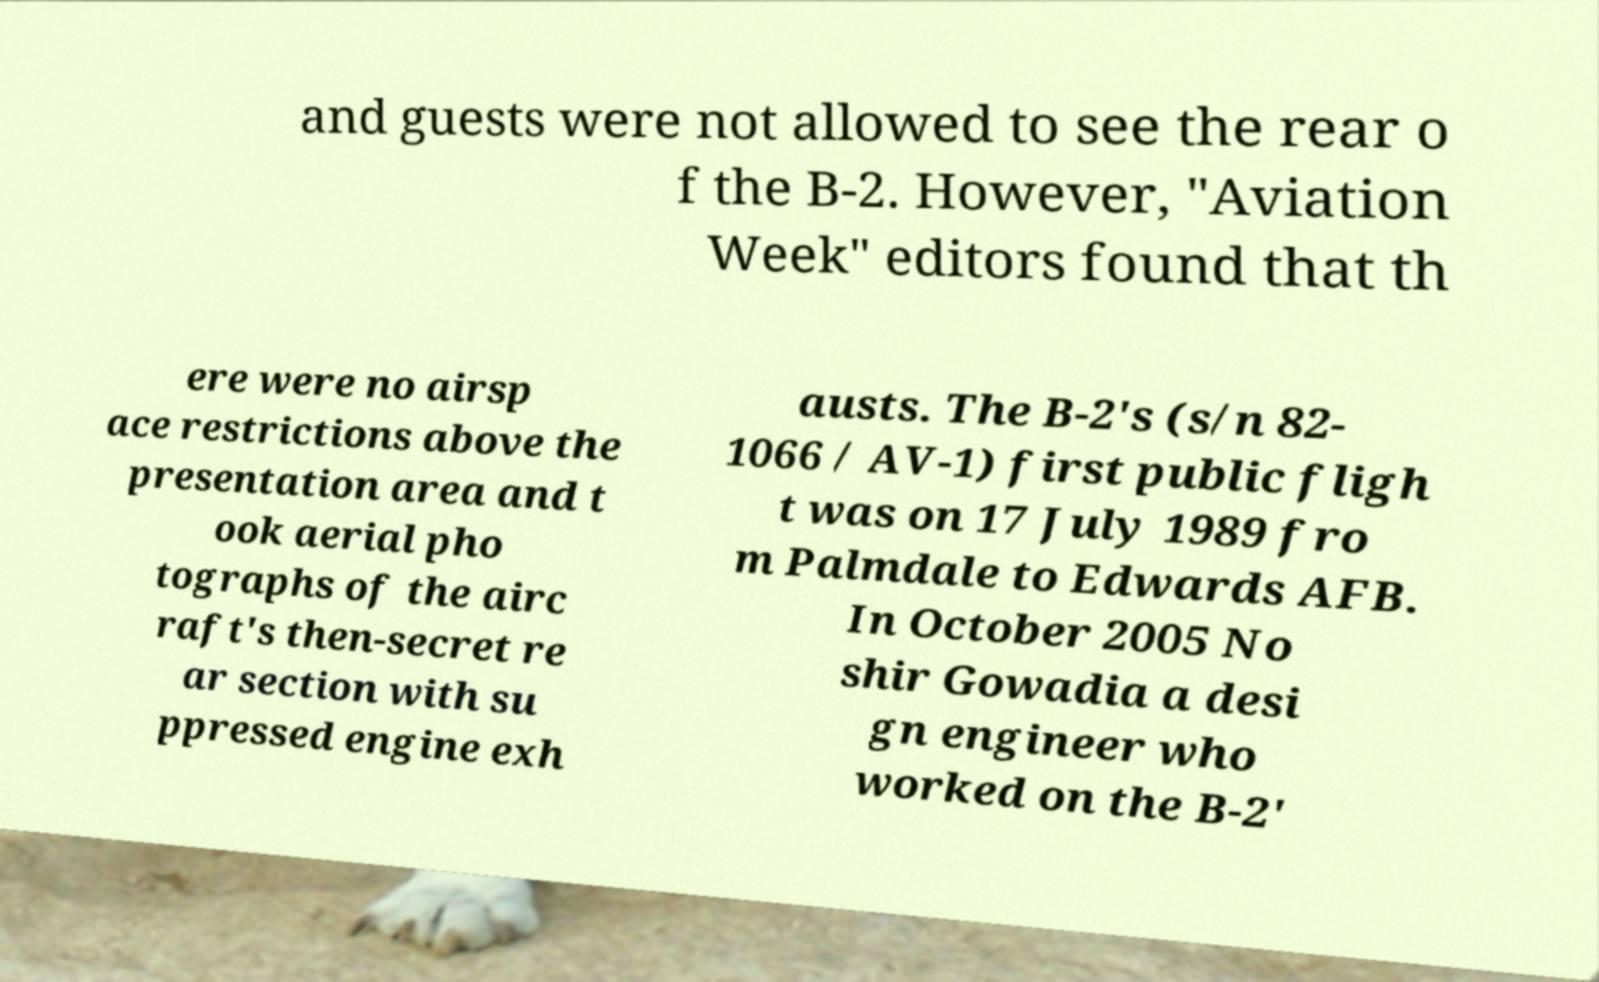Please read and relay the text visible in this image. What does it say? and guests were not allowed to see the rear o f the B-2. However, "Aviation Week" editors found that th ere were no airsp ace restrictions above the presentation area and t ook aerial pho tographs of the airc raft's then-secret re ar section with su ppressed engine exh austs. The B-2's (s/n 82- 1066 / AV-1) first public fligh t was on 17 July 1989 fro m Palmdale to Edwards AFB. In October 2005 No shir Gowadia a desi gn engineer who worked on the B-2' 